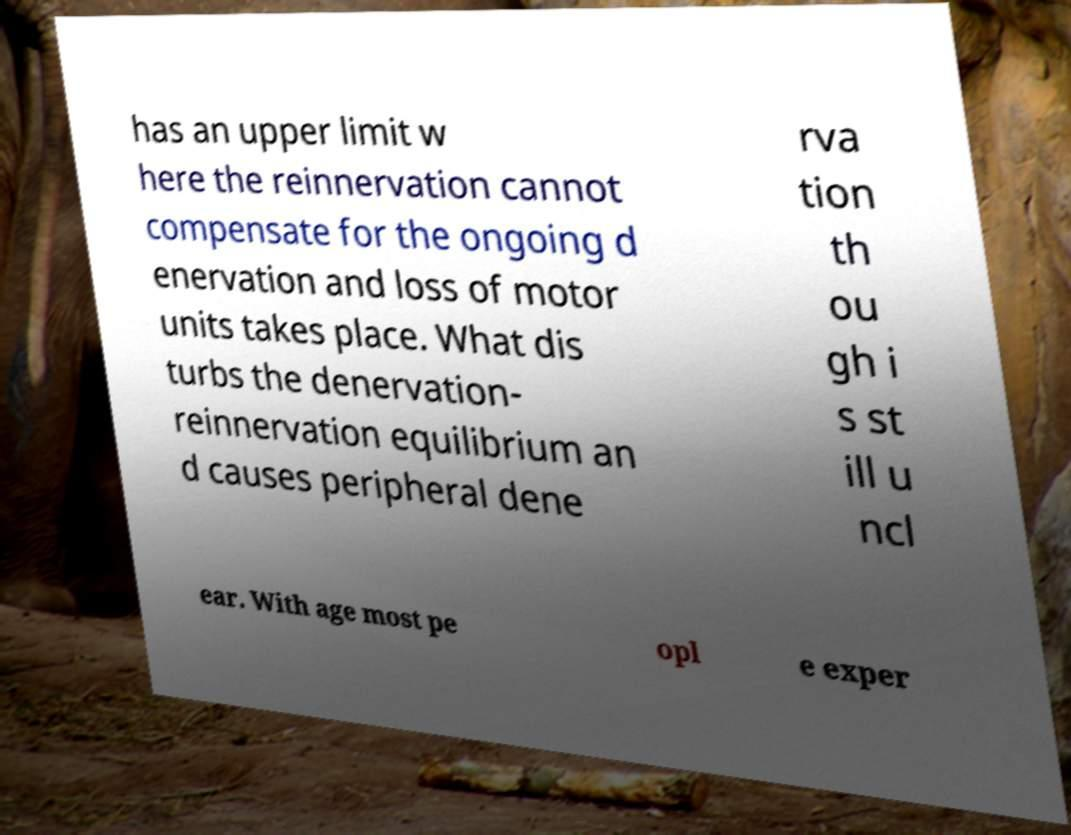Can you read and provide the text displayed in the image?This photo seems to have some interesting text. Can you extract and type it out for me? has an upper limit w here the reinnervation cannot compensate for the ongoing d enervation and loss of motor units takes place. What dis turbs the denervation- reinnervation equilibrium an d causes peripheral dene rva tion th ou gh i s st ill u ncl ear. With age most pe opl e exper 